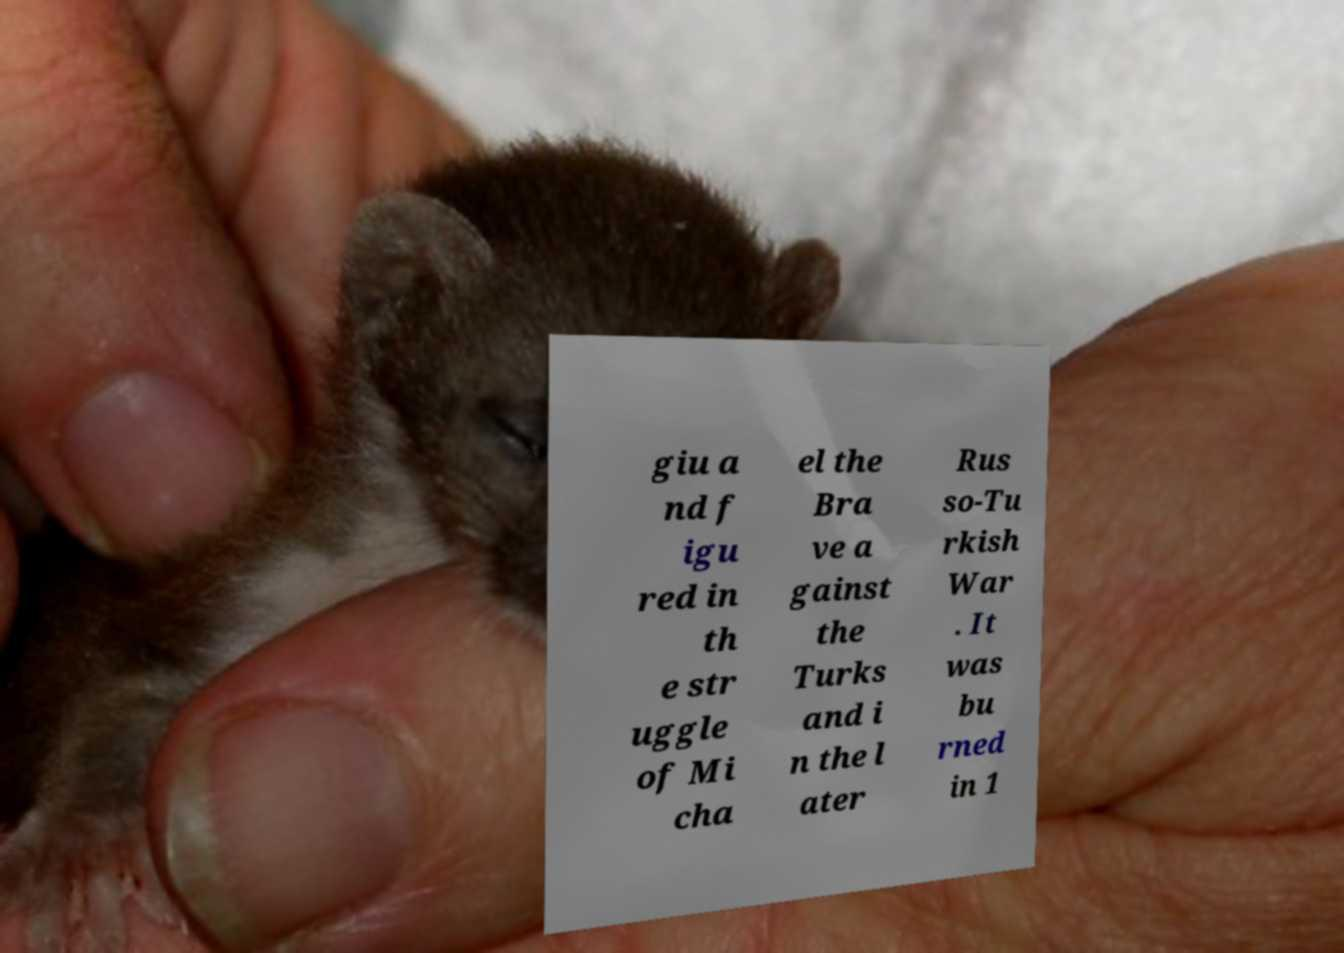Please identify and transcribe the text found in this image. giu a nd f igu red in th e str uggle of Mi cha el the Bra ve a gainst the Turks and i n the l ater Rus so-Tu rkish War . It was bu rned in 1 